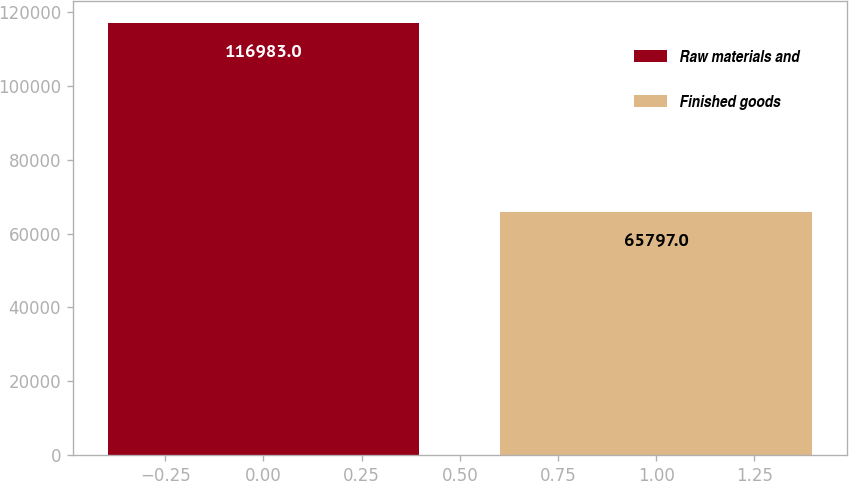Convert chart to OTSL. <chart><loc_0><loc_0><loc_500><loc_500><bar_chart><fcel>Raw materials and<fcel>Finished goods<nl><fcel>116983<fcel>65797<nl></chart> 